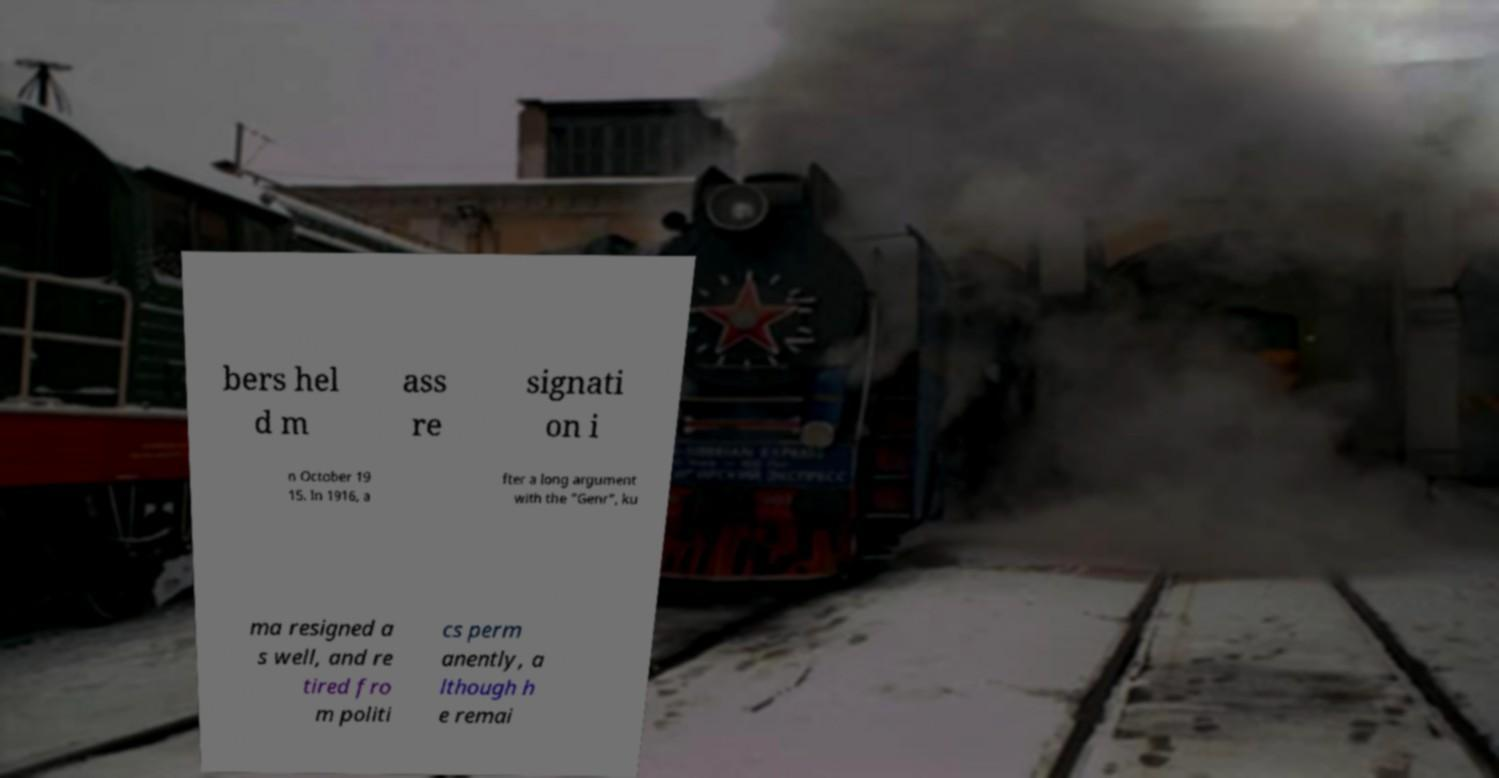Please read and relay the text visible in this image. What does it say? bers hel d m ass re signati on i n October 19 15. In 1916, a fter a long argument with the "Genr", ku ma resigned a s well, and re tired fro m politi cs perm anently, a lthough h e remai 